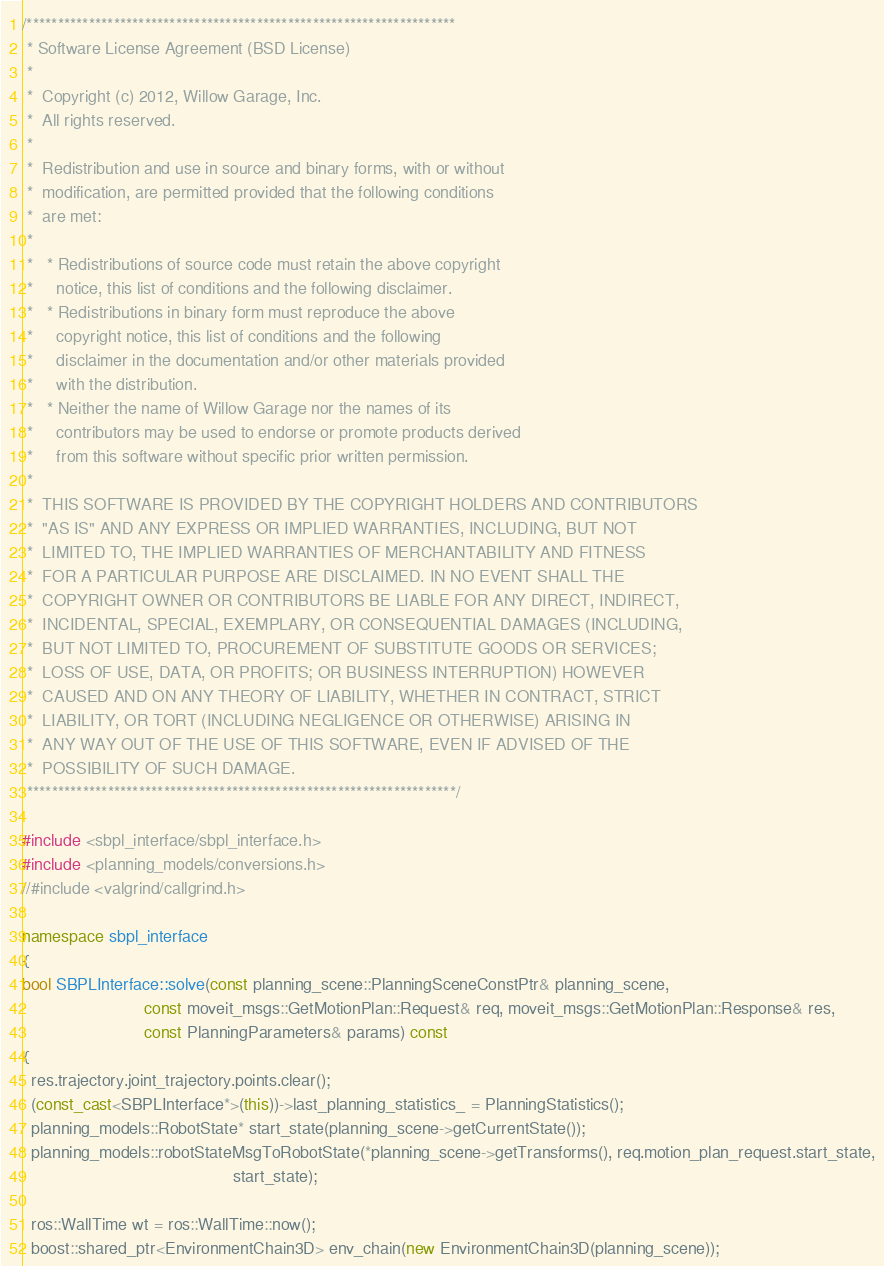<code> <loc_0><loc_0><loc_500><loc_500><_C++_>/*********************************************************************
 * Software License Agreement (BSD License)
 *
 *  Copyright (c) 2012, Willow Garage, Inc.
 *  All rights reserved.
 *
 *  Redistribution and use in source and binary forms, with or without
 *  modification, are permitted provided that the following conditions
 *  are met:
 *
 *   * Redistributions of source code must retain the above copyright
 *     notice, this list of conditions and the following disclaimer.
 *   * Redistributions in binary form must reproduce the above
 *     copyright notice, this list of conditions and the following
 *     disclaimer in the documentation and/or other materials provided
 *     with the distribution.
 *   * Neither the name of Willow Garage nor the names of its
 *     contributors may be used to endorse or promote products derived
 *     from this software without specific prior written permission.
 *
 *  THIS SOFTWARE IS PROVIDED BY THE COPYRIGHT HOLDERS AND CONTRIBUTORS
 *  "AS IS" AND ANY EXPRESS OR IMPLIED WARRANTIES, INCLUDING, BUT NOT
 *  LIMITED TO, THE IMPLIED WARRANTIES OF MERCHANTABILITY AND FITNESS
 *  FOR A PARTICULAR PURPOSE ARE DISCLAIMED. IN NO EVENT SHALL THE
 *  COPYRIGHT OWNER OR CONTRIBUTORS BE LIABLE FOR ANY DIRECT, INDIRECT,
 *  INCIDENTAL, SPECIAL, EXEMPLARY, OR CONSEQUENTIAL DAMAGES (INCLUDING,
 *  BUT NOT LIMITED TO, PROCUREMENT OF SUBSTITUTE GOODS OR SERVICES;
 *  LOSS OF USE, DATA, OR PROFITS; OR BUSINESS INTERRUPTION) HOWEVER
 *  CAUSED AND ON ANY THEORY OF LIABILITY, WHETHER IN CONTRACT, STRICT
 *  LIABILITY, OR TORT (INCLUDING NEGLIGENCE OR OTHERWISE) ARISING IN
 *  ANY WAY OUT OF THE USE OF THIS SOFTWARE, EVEN IF ADVISED OF THE
 *  POSSIBILITY OF SUCH DAMAGE.
 *********************************************************************/

#include <sbpl_interface/sbpl_interface.h>
#include <planning_models/conversions.h>
//#include <valgrind/callgrind.h>

namespace sbpl_interface
{
bool SBPLInterface::solve(const planning_scene::PlanningSceneConstPtr& planning_scene,
                          const moveit_msgs::GetMotionPlan::Request& req, moveit_msgs::GetMotionPlan::Response& res,
                          const PlanningParameters& params) const
{
  res.trajectory.joint_trajectory.points.clear();
  (const_cast<SBPLInterface*>(this))->last_planning_statistics_ = PlanningStatistics();
  planning_models::RobotState* start_state(planning_scene->getCurrentState());
  planning_models::robotStateMsgToRobotState(*planning_scene->getTransforms(), req.motion_plan_request.start_state,
                                             start_state);

  ros::WallTime wt = ros::WallTime::now();
  boost::shared_ptr<EnvironmentChain3D> env_chain(new EnvironmentChain3D(planning_scene));</code> 